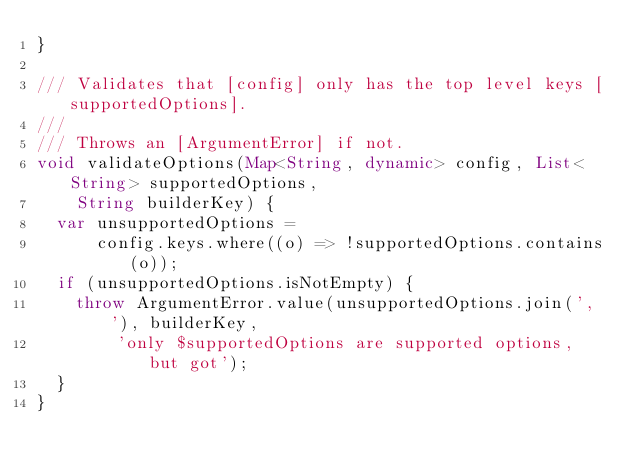<code> <loc_0><loc_0><loc_500><loc_500><_Dart_>}

/// Validates that [config] only has the top level keys [supportedOptions].
///
/// Throws an [ArgumentError] if not.
void validateOptions(Map<String, dynamic> config, List<String> supportedOptions,
    String builderKey) {
  var unsupportedOptions =
      config.keys.where((o) => !supportedOptions.contains(o));
  if (unsupportedOptions.isNotEmpty) {
    throw ArgumentError.value(unsupportedOptions.join(', '), builderKey,
        'only $supportedOptions are supported options, but got');
  }
}
</code> 